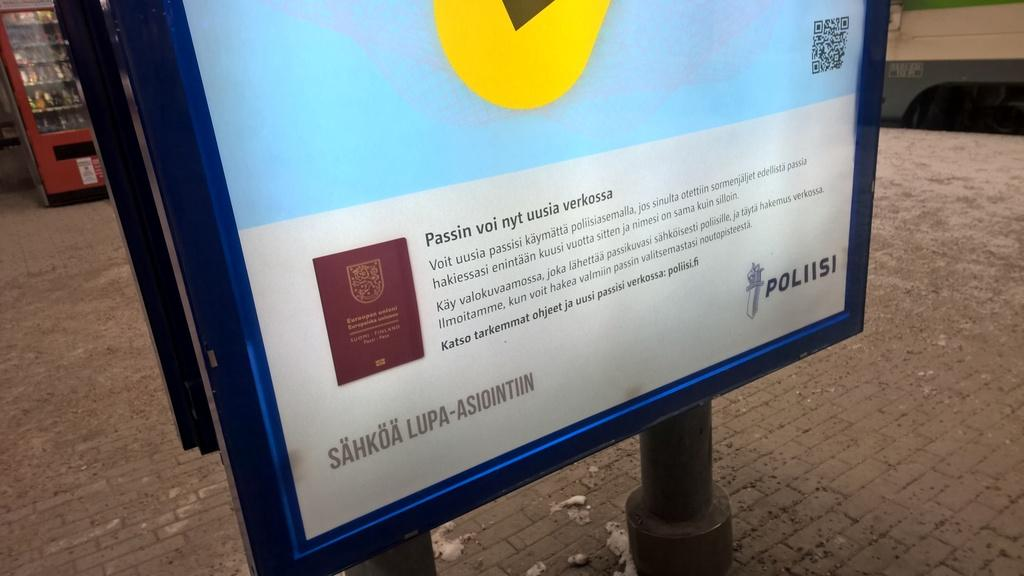<image>
Relay a brief, clear account of the picture shown. a computer image with an arrow and the word Pollisi at the bottom 